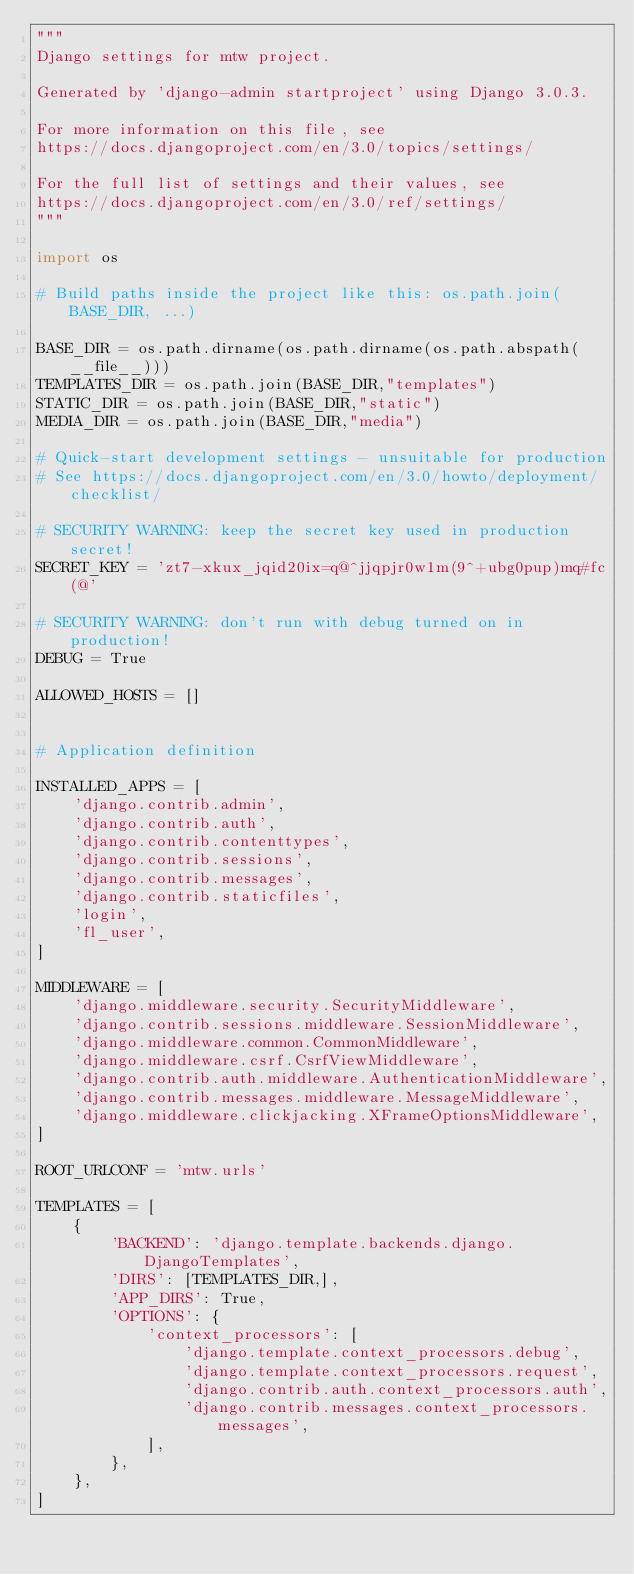<code> <loc_0><loc_0><loc_500><loc_500><_Python_>"""
Django settings for mtw project.

Generated by 'django-admin startproject' using Django 3.0.3.

For more information on this file, see
https://docs.djangoproject.com/en/3.0/topics/settings/

For the full list of settings and their values, see
https://docs.djangoproject.com/en/3.0/ref/settings/
"""

import os

# Build paths inside the project like this: os.path.join(BASE_DIR, ...)

BASE_DIR = os.path.dirname(os.path.dirname(os.path.abspath(__file__)))
TEMPLATES_DIR = os.path.join(BASE_DIR,"templates")
STATIC_DIR = os.path.join(BASE_DIR,"static")
MEDIA_DIR = os.path.join(BASE_DIR,"media")

# Quick-start development settings - unsuitable for production
# See https://docs.djangoproject.com/en/3.0/howto/deployment/checklist/

# SECURITY WARNING: keep the secret key used in production secret!
SECRET_KEY = 'zt7-xkux_jqid20ix=q@^jjqpjr0w1m(9^+ubg0pup)mq#fc(@'

# SECURITY WARNING: don't run with debug turned on in production!
DEBUG = True

ALLOWED_HOSTS = []


# Application definition

INSTALLED_APPS = [
    'django.contrib.admin',
    'django.contrib.auth',
    'django.contrib.contenttypes',
    'django.contrib.sessions',
    'django.contrib.messages',
    'django.contrib.staticfiles',
    'login',
    'fl_user',
]

MIDDLEWARE = [
    'django.middleware.security.SecurityMiddleware',
    'django.contrib.sessions.middleware.SessionMiddleware',
    'django.middleware.common.CommonMiddleware',
    'django.middleware.csrf.CsrfViewMiddleware',
    'django.contrib.auth.middleware.AuthenticationMiddleware',
    'django.contrib.messages.middleware.MessageMiddleware',
    'django.middleware.clickjacking.XFrameOptionsMiddleware',
]

ROOT_URLCONF = 'mtw.urls'

TEMPLATES = [
    {
        'BACKEND': 'django.template.backends.django.DjangoTemplates',
        'DIRS': [TEMPLATES_DIR,],
        'APP_DIRS': True,
        'OPTIONS': {
            'context_processors': [
                'django.template.context_processors.debug',
                'django.template.context_processors.request',
                'django.contrib.auth.context_processors.auth',
                'django.contrib.messages.context_processors.messages',
            ],
        },
    },
]
</code> 